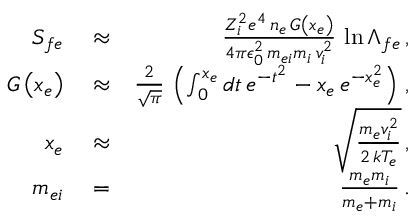<formula> <loc_0><loc_0><loc_500><loc_500>\begin{array} { r l r } { S _ { f e } } & \approx } & { \frac { Z _ { i } ^ { 2 } e ^ { 4 } \, n _ { e } \, G \left ( x _ { e } \right ) } { 4 \pi \epsilon _ { 0 } ^ { 2 } \, m _ { e i } m _ { i } \, v _ { i } ^ { 2 } } \, \ln \Lambda _ { f e } \, , } \\ { G \left ( x _ { e } \right ) } & \approx } & { \frac { 2 } { \sqrt { \pi } } \, \left ( \int _ { 0 } ^ { x _ { e } } d t \, e ^ { - t ^ { 2 } } - x _ { e } \, e ^ { - x _ { e } ^ { 2 } } \right ) \, , } \\ { x _ { e } } & \approx } & { \sqrt { \frac { m _ { e } v _ { i } ^ { 2 } } { 2 \, k T _ { e } } } \, , } \\ { m _ { e i } } & = } & { \frac { m _ { e } m _ { i } } { m _ { e } + m _ { i } } \, . } \end{array}</formula> 